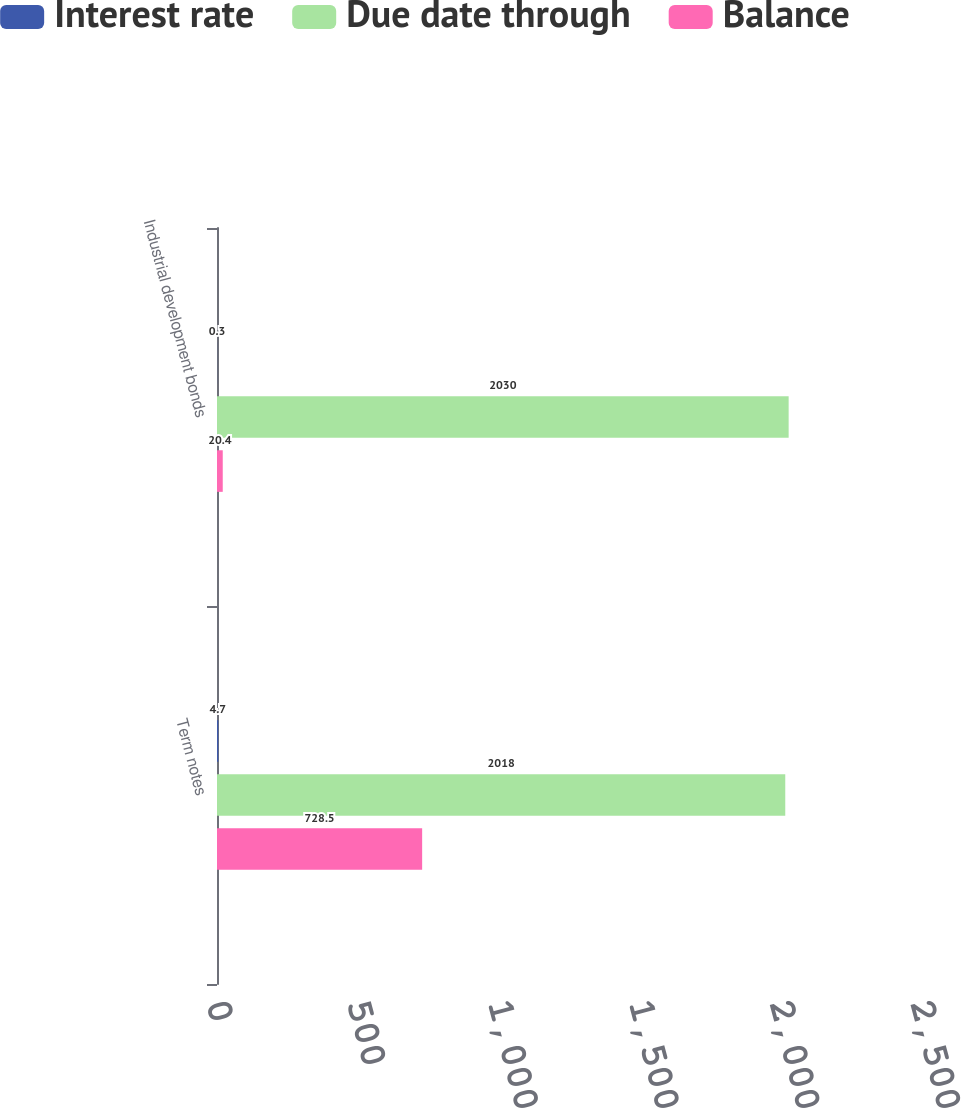Convert chart to OTSL. <chart><loc_0><loc_0><loc_500><loc_500><stacked_bar_chart><ecel><fcel>Term notes<fcel>Industrial development bonds<nl><fcel>Interest rate<fcel>4.7<fcel>0.3<nl><fcel>Due date through<fcel>2018<fcel>2030<nl><fcel>Balance<fcel>728.5<fcel>20.4<nl></chart> 